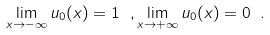<formula> <loc_0><loc_0><loc_500><loc_500>\lim _ { x \rightarrow - \infty } u _ { 0 } ( x ) = 1 \ , \lim _ { x \rightarrow + \infty } u _ { 0 } ( x ) = 0 \ .</formula> 